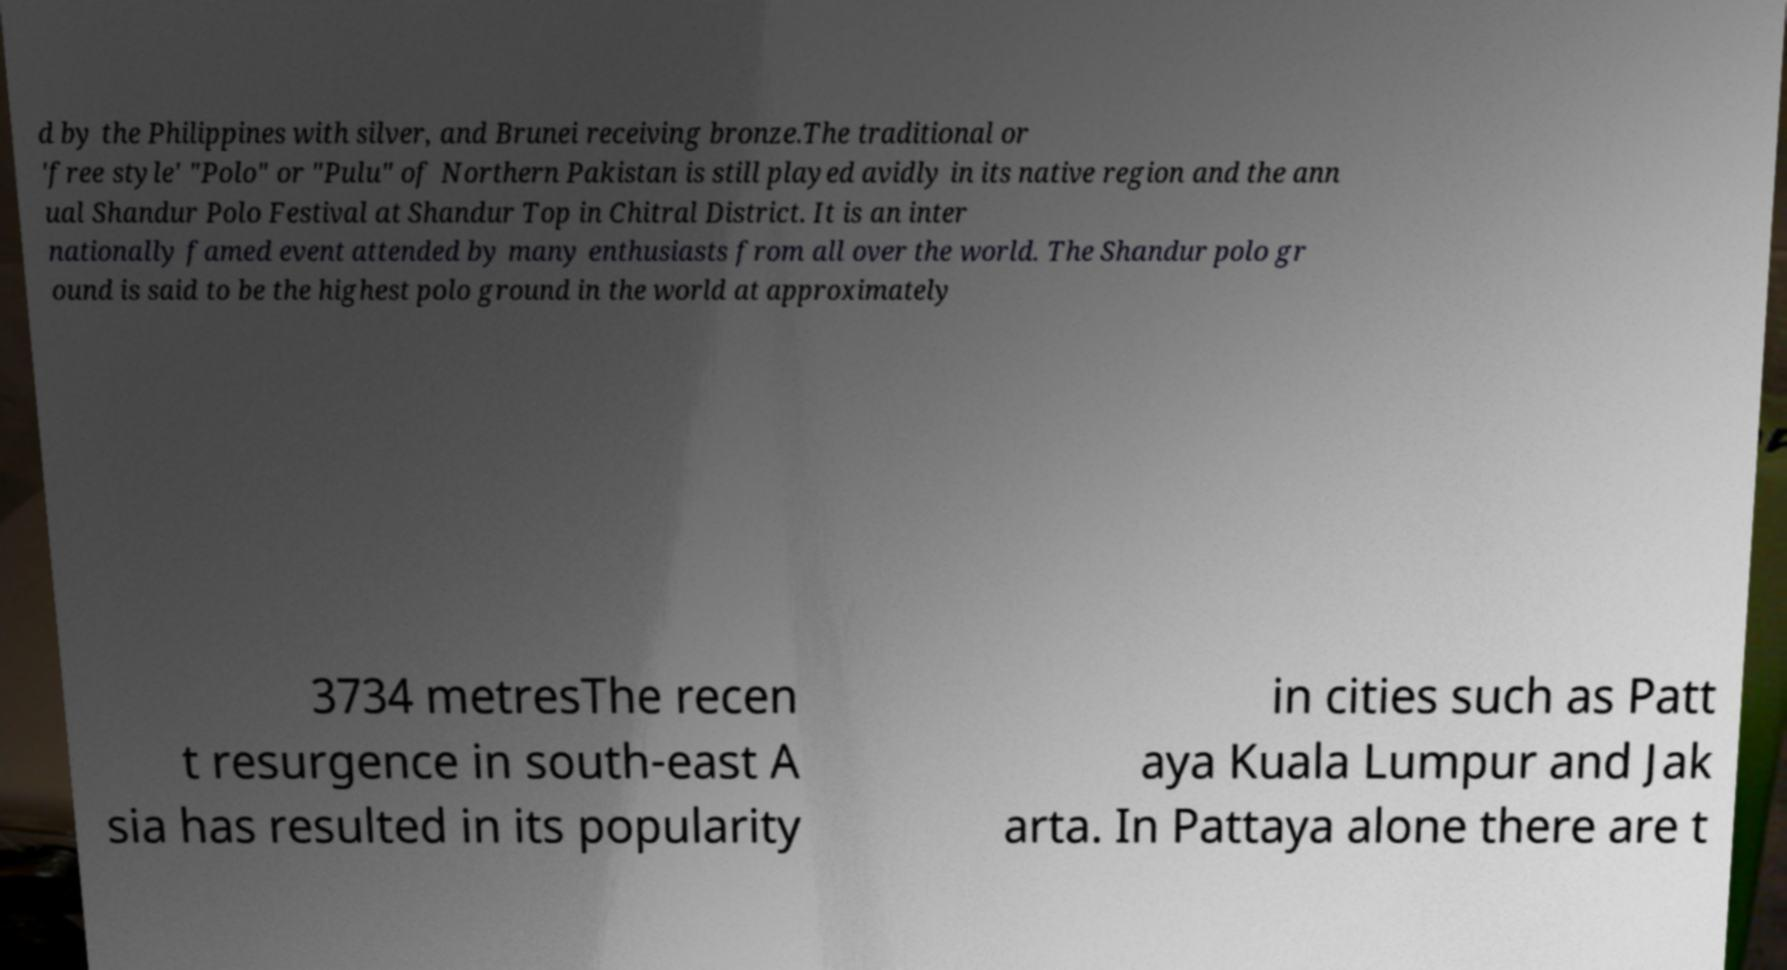What messages or text are displayed in this image? I need them in a readable, typed format. d by the Philippines with silver, and Brunei receiving bronze.The traditional or 'free style' "Polo" or "Pulu" of Northern Pakistan is still played avidly in its native region and the ann ual Shandur Polo Festival at Shandur Top in Chitral District. It is an inter nationally famed event attended by many enthusiasts from all over the world. The Shandur polo gr ound is said to be the highest polo ground in the world at approximately 3734 metresThe recen t resurgence in south-east A sia has resulted in its popularity in cities such as Patt aya Kuala Lumpur and Jak arta. In Pattaya alone there are t 